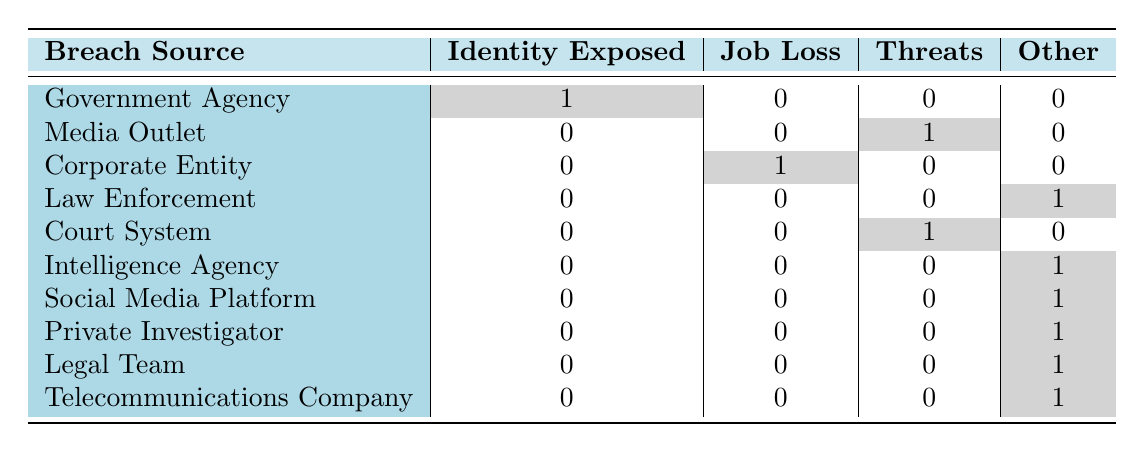What is the breach source that resulted in an "Identity Exposed" consequence? The table shows the breach sources listed along with their corresponding consequences. Under the "Identity Exposed" column, only the "Government Agency" has a count of 1, indicating it is the source that resulted in this consequence.
Answer: Government Agency How many different breach sources led to "Job Loss"? By examining the "Job Loss" column, there is a count of 1 for "Corporate Entity" which indicates it is the only breach source that led to the consequence of Job Loss.
Answer: 1 Is there a breach source that led to "Witness Intimidation"? Looking at the "Witness Intimidation" column, the "Media Outlet" shows a count of 1. Therefore, there is a breach source that resulted in this consequence.
Answer: Yes What is the total number of breach sources that have resulted in at least one consequence listed in the table? The table provides 10 breach sources (Government Agency, Media Outlet, Corporate Entity, Law Enforcement, Court System, Intelligence Agency, Social Media Platform, Private Investigator, Legal Team, and Telecommunications Company). Each source is paired with at least one consequence listed in the table, resulting in a total of 10 distinct sources.
Answer: 10 Which consequence is associated with the highest number of breach sources? The table indicates that the "Other" category has counts associated with 7 different breach sources. In contrast, the other consequences (Identity Exposed, Job Loss, Threats) have counts associated with fewer sources, making "Other" the highest.
Answer: Other How many breach sources are associated with "Threats to Family"? In the table, only the "Court System" shows a count of 1 under "Threats," indicating that it is the sole breach source leading to this consequence.
Answer: 1 Is there any breach source that resulted in "International Incident"? Upon review, the "Intelligence Agency" is the only source that has an associated consequence of "International Incident," confirming a breach source for this outcome.
Answer: Yes What is the proportion of breach sources that have resulted in some form of harassment (such as "Witness Intimidation" or "Online Harassment")? The "Witness Intimidation" from "Media Outlet" and "Online Harassment" from "Social Media Platform" are the two identified cases. Thus, out of 10 breach sources, 2 resulted in harassment, leading to a proportion of 2/10 or 0.2.
Answer: 0.2 